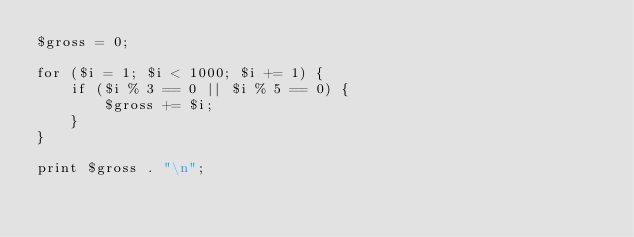<code> <loc_0><loc_0><loc_500><loc_500><_Perl_>$gross = 0;

for ($i = 1; $i < 1000; $i += 1) {
    if ($i % 3 == 0 || $i % 5 == 0) {
        $gross += $i;
    }
}

print $gross . "\n";
</code> 